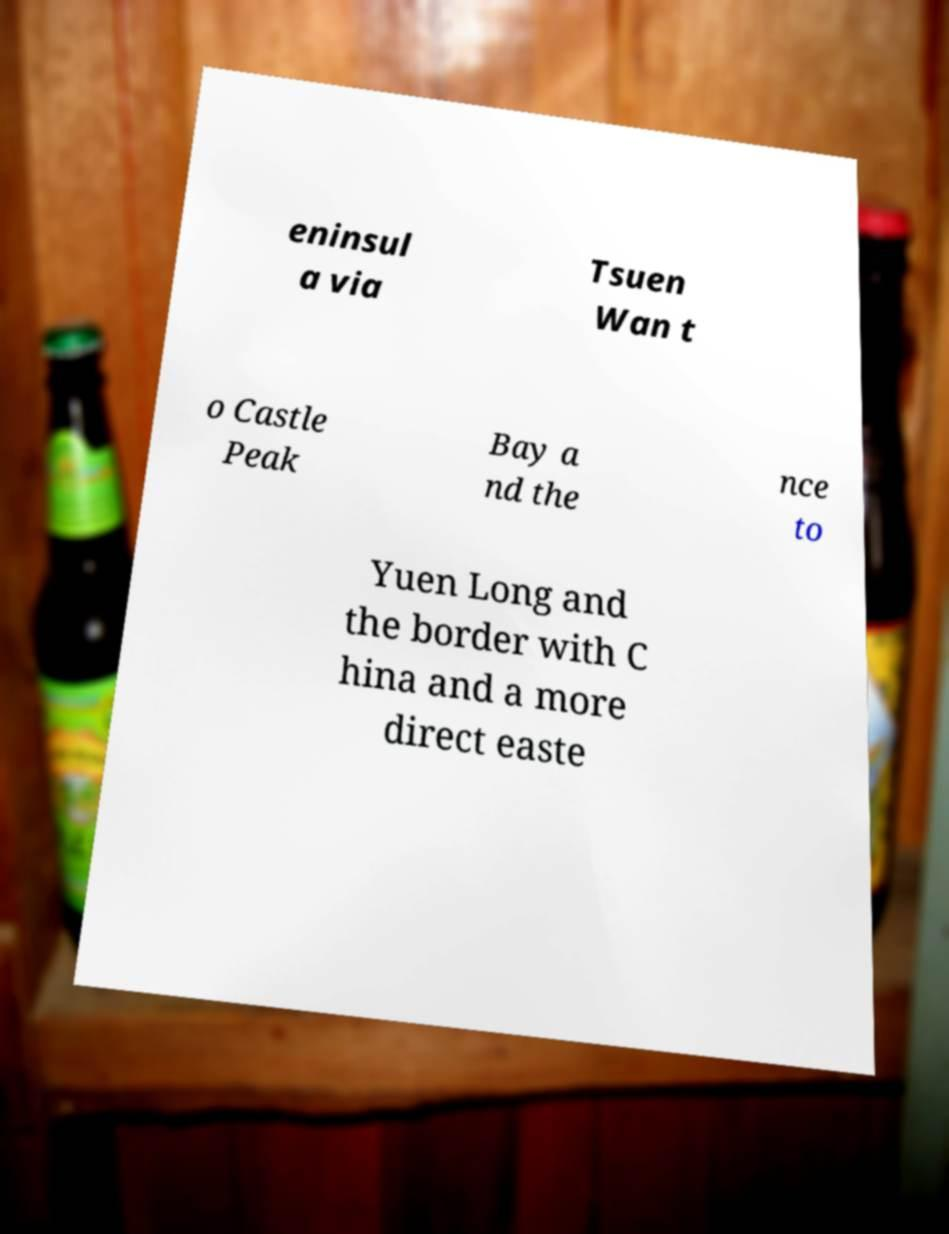I need the written content from this picture converted into text. Can you do that? eninsul a via Tsuen Wan t o Castle Peak Bay a nd the nce to Yuen Long and the border with C hina and a more direct easte 